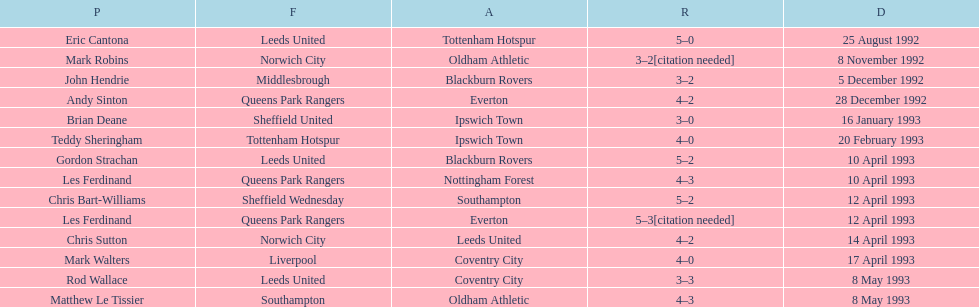In the 1992-1993 premier league, what was the total number of hat tricks scored by all players? 14. 